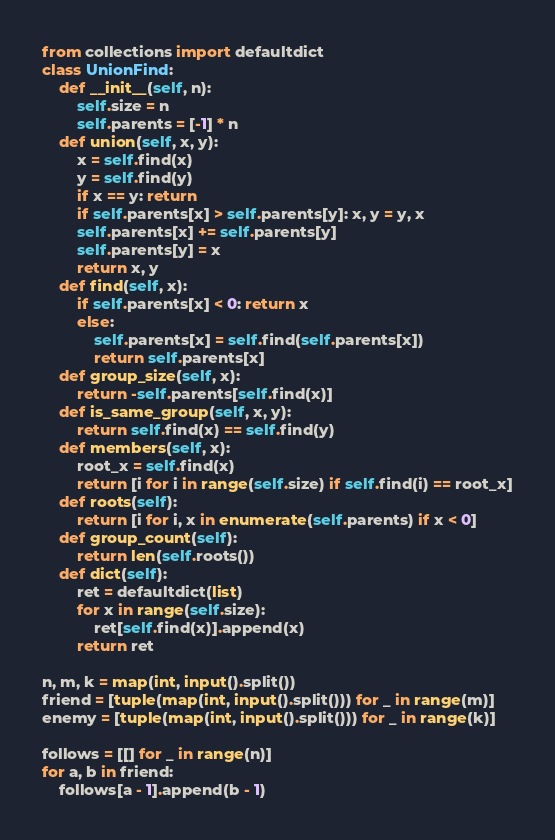Convert code to text. <code><loc_0><loc_0><loc_500><loc_500><_Python_>from collections import defaultdict
class UnionFind:
    def __init__(self, n):
        self.size = n
        self.parents = [-1] * n
    def union(self, x, y):
        x = self.find(x)
        y = self.find(y)
        if x == y: return
        if self.parents[x] > self.parents[y]: x, y = y, x
        self.parents[x] += self.parents[y]
        self.parents[y] = x
        return x, y
    def find(self, x):
        if self.parents[x] < 0: return x
        else:
            self.parents[x] = self.find(self.parents[x])
            return self.parents[x]
    def group_size(self, x):
        return -self.parents[self.find(x)]
    def is_same_group(self, x, y):
        return self.find(x) == self.find(y)
    def members(self, x):
        root_x = self.find(x)
        return [i for i in range(self.size) if self.find(i) == root_x]
    def roots(self):
        return [i for i, x in enumerate(self.parents) if x < 0]
    def group_count(self):
        return len(self.roots())
    def dict(self):
        ret = defaultdict(list)
        for x in range(self.size):
            ret[self.find(x)].append(x)
        return ret

n, m, k = map(int, input().split())
friend = [tuple(map(int, input().split())) for _ in range(m)]
enemy = [tuple(map(int, input().split())) for _ in range(k)]

follows = [[] for _ in range(n)]
for a, b in friend:
    follows[a - 1].append(b - 1)</code> 